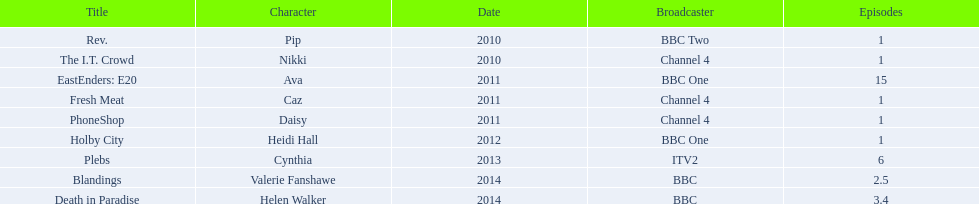Which characters were featured in more then one episode? Ava, Cynthia, Valerie Fanshawe, Helen Walker. Which of these were not in 2014? Ava, Cynthia. Which one of those was not on a bbc broadcaster? Cynthia. 